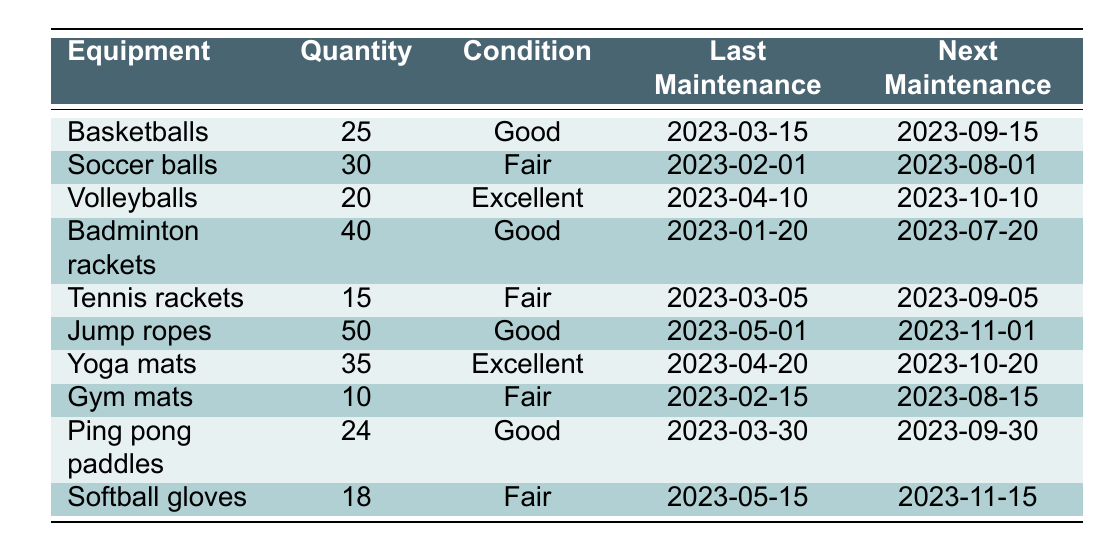What is the condition of the badminton rackets? The table lists "Badminton rackets" under the "Equipment" column, and corresponding to this row, the "Condition" column states "Good".
Answer: Good When is the next maintenance for the volleyballs? Looking under the "Volleyballs" row, the "Next Maintenance" column specifies the date "2023-10-10".
Answer: 2023-10-10 How many gym mats are in fair condition? Referring to the "Gym mats" row, it states the quantity as "10" and the condition as "Fair".
Answer: 10 Is the number of jump ropes greater than the number of tennis rackets? The row for "Jump ropes" shows 50, while "Tennis rackets" shows 15. Comparing these two values, 50 is indeed greater than 15.
Answer: Yes What is the total quantity of equipment that is in 'Fair' condition? Add the quantities from each equipment with 'Fair' condition: Soccer balls (30) + Tennis rackets (15) + Gym mats (10) + Softball gloves (18), the total is 30 + 15 + 10 + 18 = 73.
Answer: 73 What is the difference in quantity between the equipment with the most and least number of items? The maximum quantity is for "Jump ropes" with 50 and the minimum is for "Gym mats" with 10. The difference is 50 - 10 = 40.
Answer: 40 How many pieces of equipment have their next maintenance scheduled after October 1, 2023? Looking through the "Next Maintenance" dates, equipment with dates beyond October 1, 2023, are Jump ropes (2023-11-01), Yoga mats (2023-10-20), and Softball gloves (2023-11-15). That totals 3 pieces of equipment.
Answer: 3 Which equipment has the highest quantity and what is its condition? Jump ropes have the highest quantity of 50. The condition for jump ropes listed in the table is "Good".
Answer: Jump ropes, Good Are there more basketballs or soccer balls available in the inventory? The table shows 25 basketballs and 30 soccer balls. Since 30 is greater than 25, soccer balls are more in quantity.
Answer: Soccer balls 